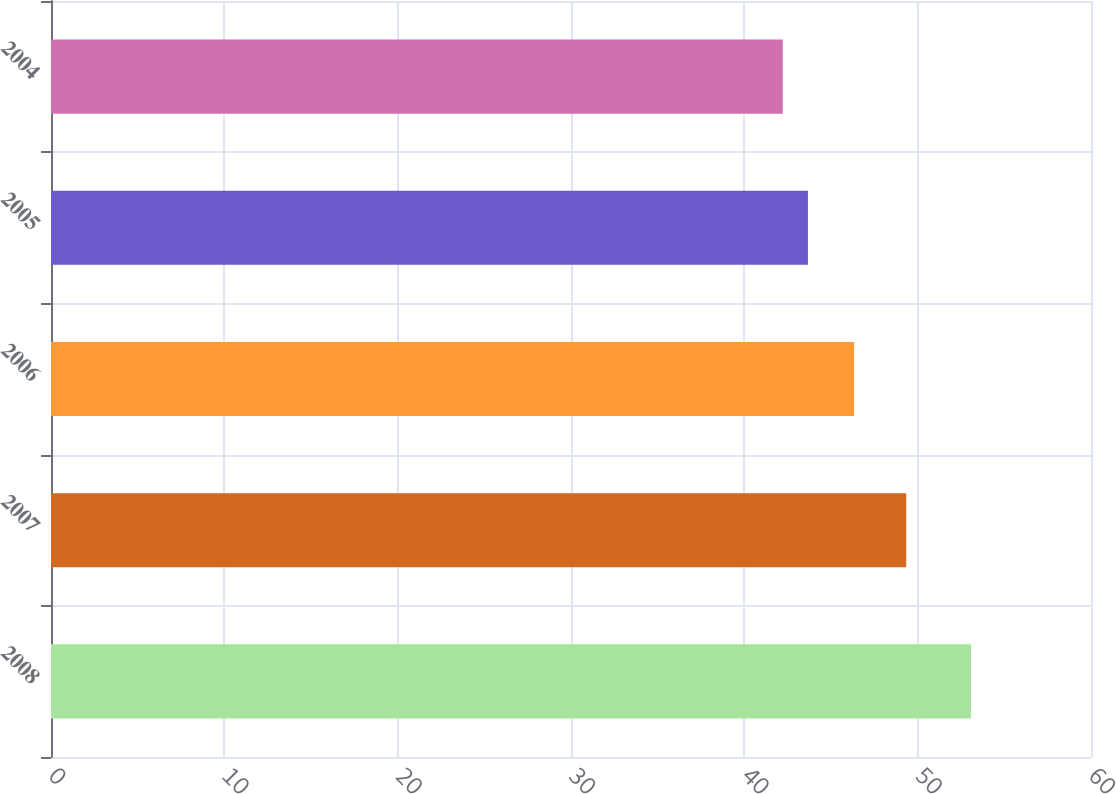Convert chart to OTSL. <chart><loc_0><loc_0><loc_500><loc_500><bar_chart><fcel>2008<fcel>2007<fcel>2006<fcel>2005<fcel>2004<nl><fcel>53.08<fcel>49.34<fcel>46.33<fcel>43.67<fcel>42.22<nl></chart> 